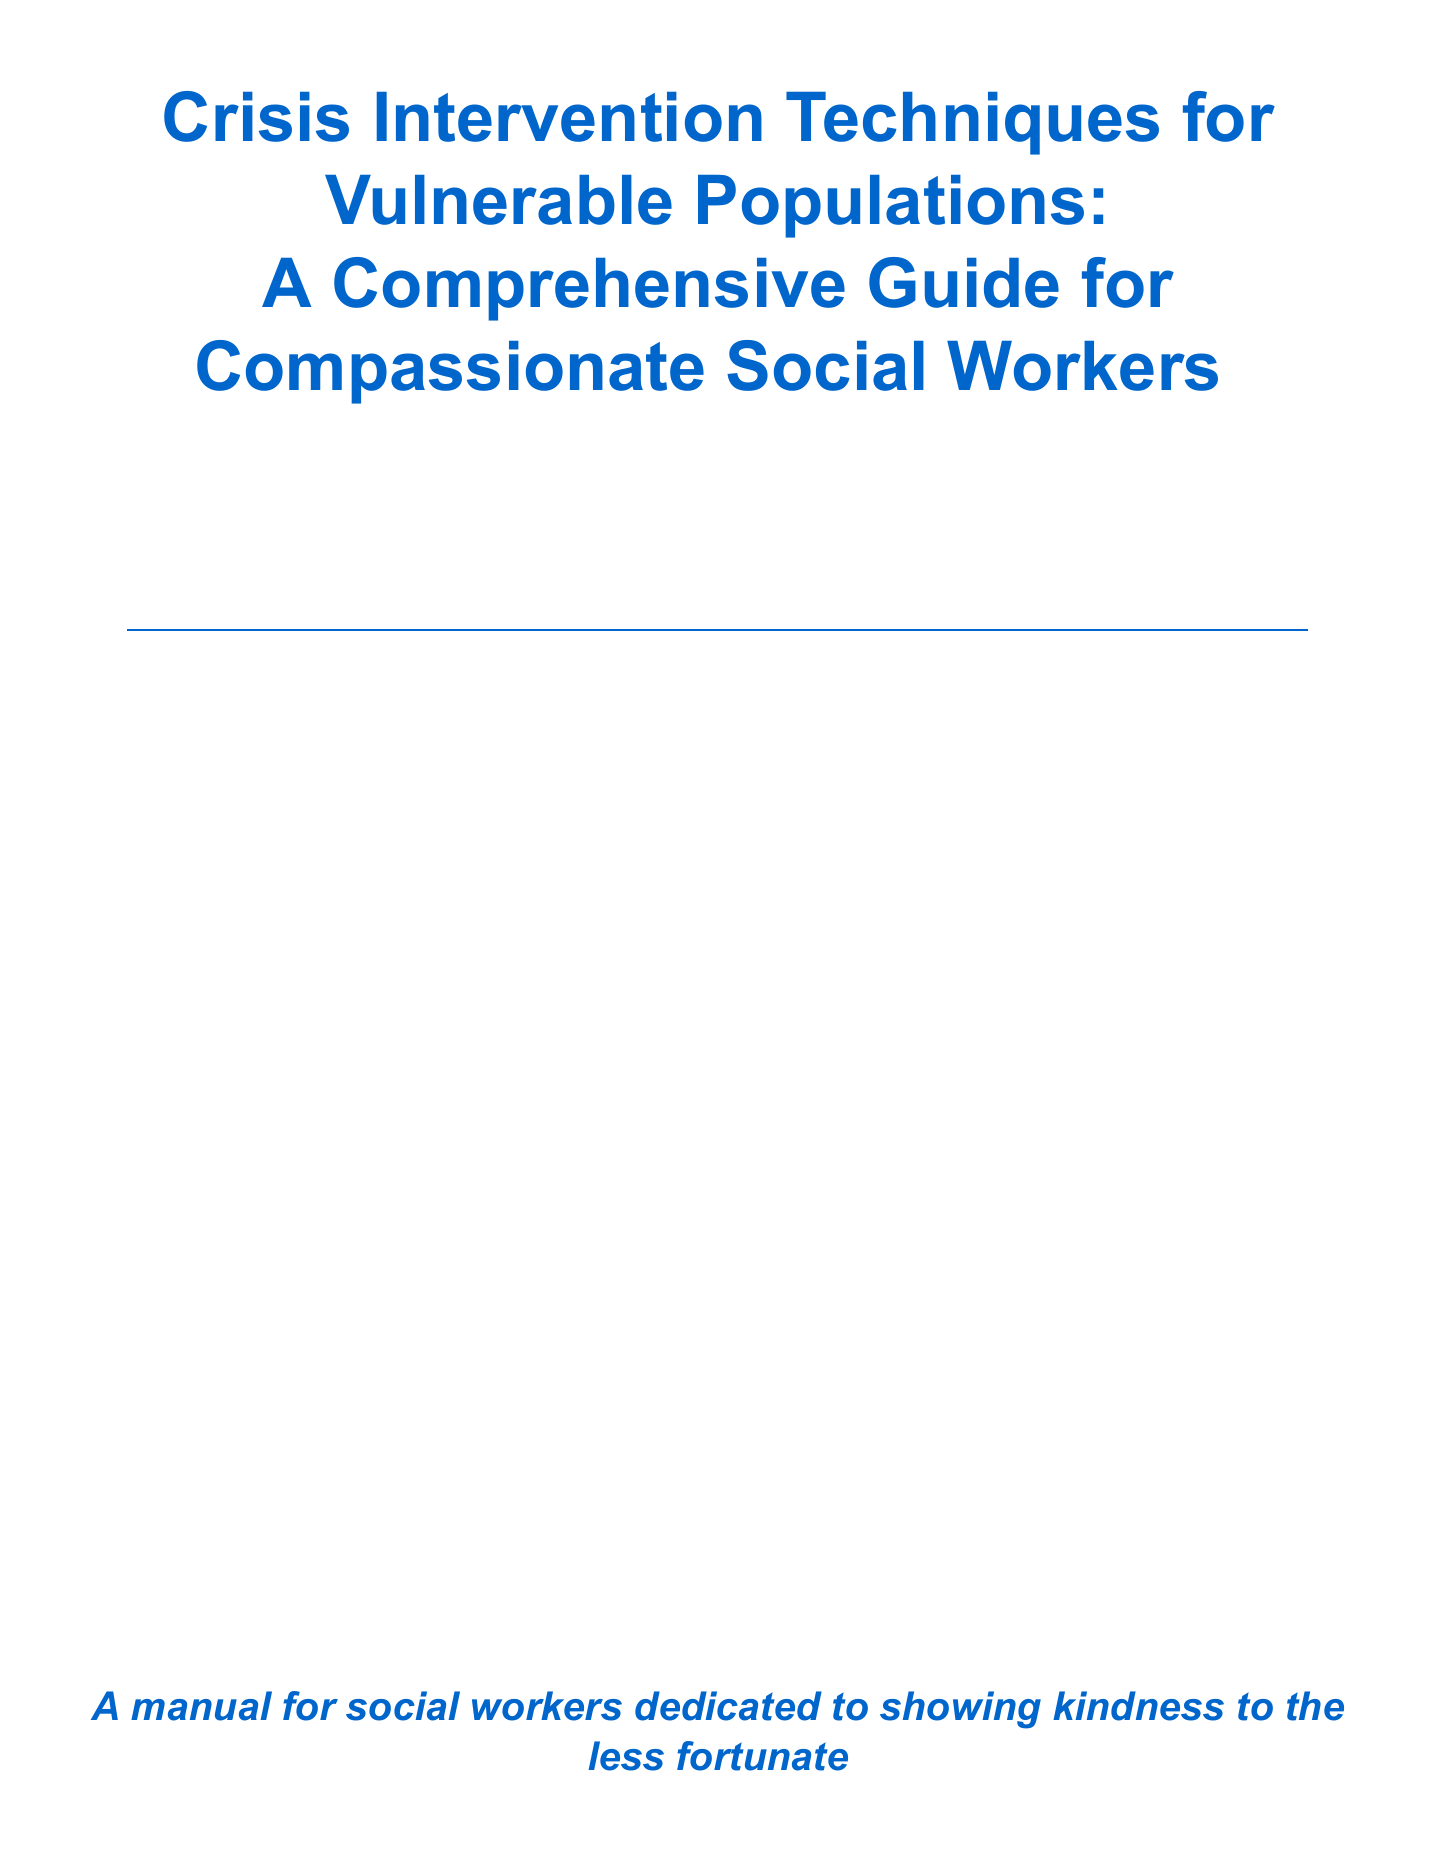what is the title of the manual? The title is stated at the beginning of the document and emphasizes crisis intervention for vulnerable populations.
Answer: Crisis Intervention Techniques for Vulnerable Populations: A Comprehensive Guide for Compassionate Social Workers what is a common crisis affecting vulnerable populations? Common crises are listed within the section on types of crises, showcasing the challenges faced by these groups.
Answer: homelessness what is one technique for establishing rapport with clients? The manual provides several techniques in the core principles section, specifically in building relationships.
Answer: active listening what model is utilized for Psychological First Aid? The specific entity providing the model is mentioned in the section discussing specific intervention techniques.
Answer: World Health Organization which section addresses self-care for crisis intervention workers? The manual has a dedicated section that specifically focuses on the well-being of those providing crisis interventions.
Answer: Self-Care for Crisis Intervention Workers what is one key aspect of informed consent in crisis situations? The section on legal and ethical considerations outlines important elements that need to be navigated during crisis interventions.
Answer: client autonomy how many specific intervention techniques are listed in the manual? The document enumerates the techniques in the specific intervention techniques section, providing insight into methods used.
Answer: three what is one cultural competence resource mentioned in the manual? Cultural competence is emphasized, with resources suggested in the relevant section, illustrating the importance of understanding cultural differences.
Answer: National Association of Social Workers 